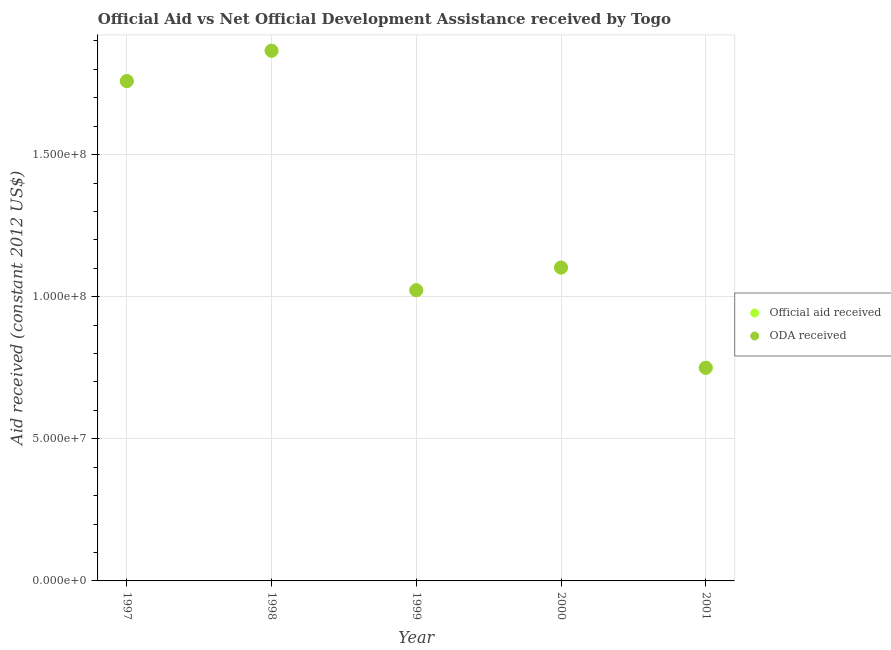How many different coloured dotlines are there?
Make the answer very short. 2. What is the official aid received in 1997?
Ensure brevity in your answer.  1.76e+08. Across all years, what is the maximum official aid received?
Provide a short and direct response. 1.87e+08. Across all years, what is the minimum official aid received?
Your answer should be compact. 7.50e+07. What is the total official aid received in the graph?
Keep it short and to the point. 6.50e+08. What is the difference between the official aid received in 1997 and that in 2000?
Offer a terse response. 6.56e+07. What is the difference between the oda received in 2001 and the official aid received in 2000?
Offer a very short reply. -3.53e+07. What is the average official aid received per year?
Provide a short and direct response. 1.30e+08. In how many years, is the oda received greater than 110000000 US$?
Give a very brief answer. 3. What is the ratio of the official aid received in 2000 to that in 2001?
Your answer should be very brief. 1.47. Is the difference between the oda received in 1997 and 1999 greater than the difference between the official aid received in 1997 and 1999?
Your response must be concise. No. What is the difference between the highest and the second highest official aid received?
Offer a terse response. 1.07e+07. What is the difference between the highest and the lowest official aid received?
Offer a terse response. 1.12e+08. In how many years, is the official aid received greater than the average official aid received taken over all years?
Ensure brevity in your answer.  2. Is the sum of the oda received in 1997 and 2001 greater than the maximum official aid received across all years?
Your answer should be compact. Yes. Does the official aid received monotonically increase over the years?
Your answer should be compact. No. Is the official aid received strictly greater than the oda received over the years?
Give a very brief answer. No. How many dotlines are there?
Ensure brevity in your answer.  2. How many years are there in the graph?
Give a very brief answer. 5. Are the values on the major ticks of Y-axis written in scientific E-notation?
Your response must be concise. Yes. Where does the legend appear in the graph?
Offer a very short reply. Center right. How many legend labels are there?
Provide a succinct answer. 2. How are the legend labels stacked?
Your answer should be very brief. Vertical. What is the title of the graph?
Give a very brief answer. Official Aid vs Net Official Development Assistance received by Togo . Does "Revenue" appear as one of the legend labels in the graph?
Provide a short and direct response. No. What is the label or title of the Y-axis?
Your answer should be compact. Aid received (constant 2012 US$). What is the Aid received (constant 2012 US$) in Official aid received in 1997?
Your answer should be compact. 1.76e+08. What is the Aid received (constant 2012 US$) in ODA received in 1997?
Make the answer very short. 1.76e+08. What is the Aid received (constant 2012 US$) in Official aid received in 1998?
Provide a short and direct response. 1.87e+08. What is the Aid received (constant 2012 US$) in ODA received in 1998?
Offer a very short reply. 1.87e+08. What is the Aid received (constant 2012 US$) in Official aid received in 1999?
Provide a short and direct response. 1.02e+08. What is the Aid received (constant 2012 US$) in ODA received in 1999?
Offer a terse response. 1.02e+08. What is the Aid received (constant 2012 US$) in Official aid received in 2000?
Your answer should be very brief. 1.10e+08. What is the Aid received (constant 2012 US$) of ODA received in 2000?
Ensure brevity in your answer.  1.10e+08. What is the Aid received (constant 2012 US$) of Official aid received in 2001?
Provide a short and direct response. 7.50e+07. What is the Aid received (constant 2012 US$) of ODA received in 2001?
Offer a very short reply. 7.50e+07. Across all years, what is the maximum Aid received (constant 2012 US$) in Official aid received?
Your answer should be very brief. 1.87e+08. Across all years, what is the maximum Aid received (constant 2012 US$) in ODA received?
Give a very brief answer. 1.87e+08. Across all years, what is the minimum Aid received (constant 2012 US$) in Official aid received?
Ensure brevity in your answer.  7.50e+07. Across all years, what is the minimum Aid received (constant 2012 US$) in ODA received?
Provide a short and direct response. 7.50e+07. What is the total Aid received (constant 2012 US$) of Official aid received in the graph?
Give a very brief answer. 6.50e+08. What is the total Aid received (constant 2012 US$) in ODA received in the graph?
Provide a succinct answer. 6.50e+08. What is the difference between the Aid received (constant 2012 US$) in Official aid received in 1997 and that in 1998?
Offer a very short reply. -1.07e+07. What is the difference between the Aid received (constant 2012 US$) in ODA received in 1997 and that in 1998?
Keep it short and to the point. -1.07e+07. What is the difference between the Aid received (constant 2012 US$) in Official aid received in 1997 and that in 1999?
Your response must be concise. 7.36e+07. What is the difference between the Aid received (constant 2012 US$) of ODA received in 1997 and that in 1999?
Your response must be concise. 7.36e+07. What is the difference between the Aid received (constant 2012 US$) of Official aid received in 1997 and that in 2000?
Provide a short and direct response. 6.56e+07. What is the difference between the Aid received (constant 2012 US$) in ODA received in 1997 and that in 2000?
Provide a short and direct response. 6.56e+07. What is the difference between the Aid received (constant 2012 US$) of Official aid received in 1997 and that in 2001?
Provide a short and direct response. 1.01e+08. What is the difference between the Aid received (constant 2012 US$) of ODA received in 1997 and that in 2001?
Your answer should be very brief. 1.01e+08. What is the difference between the Aid received (constant 2012 US$) of Official aid received in 1998 and that in 1999?
Your response must be concise. 8.43e+07. What is the difference between the Aid received (constant 2012 US$) of ODA received in 1998 and that in 1999?
Your response must be concise. 8.43e+07. What is the difference between the Aid received (constant 2012 US$) of Official aid received in 1998 and that in 2000?
Offer a terse response. 7.63e+07. What is the difference between the Aid received (constant 2012 US$) in ODA received in 1998 and that in 2000?
Make the answer very short. 7.63e+07. What is the difference between the Aid received (constant 2012 US$) in Official aid received in 1998 and that in 2001?
Make the answer very short. 1.12e+08. What is the difference between the Aid received (constant 2012 US$) in ODA received in 1998 and that in 2001?
Keep it short and to the point. 1.12e+08. What is the difference between the Aid received (constant 2012 US$) in Official aid received in 1999 and that in 2000?
Keep it short and to the point. -7.98e+06. What is the difference between the Aid received (constant 2012 US$) in ODA received in 1999 and that in 2000?
Keep it short and to the point. -7.98e+06. What is the difference between the Aid received (constant 2012 US$) in Official aid received in 1999 and that in 2001?
Make the answer very short. 2.73e+07. What is the difference between the Aid received (constant 2012 US$) in ODA received in 1999 and that in 2001?
Keep it short and to the point. 2.73e+07. What is the difference between the Aid received (constant 2012 US$) in Official aid received in 2000 and that in 2001?
Make the answer very short. 3.53e+07. What is the difference between the Aid received (constant 2012 US$) of ODA received in 2000 and that in 2001?
Provide a succinct answer. 3.53e+07. What is the difference between the Aid received (constant 2012 US$) in Official aid received in 1997 and the Aid received (constant 2012 US$) in ODA received in 1998?
Ensure brevity in your answer.  -1.07e+07. What is the difference between the Aid received (constant 2012 US$) of Official aid received in 1997 and the Aid received (constant 2012 US$) of ODA received in 1999?
Give a very brief answer. 7.36e+07. What is the difference between the Aid received (constant 2012 US$) in Official aid received in 1997 and the Aid received (constant 2012 US$) in ODA received in 2000?
Your response must be concise. 6.56e+07. What is the difference between the Aid received (constant 2012 US$) of Official aid received in 1997 and the Aid received (constant 2012 US$) of ODA received in 2001?
Ensure brevity in your answer.  1.01e+08. What is the difference between the Aid received (constant 2012 US$) of Official aid received in 1998 and the Aid received (constant 2012 US$) of ODA received in 1999?
Make the answer very short. 8.43e+07. What is the difference between the Aid received (constant 2012 US$) of Official aid received in 1998 and the Aid received (constant 2012 US$) of ODA received in 2000?
Ensure brevity in your answer.  7.63e+07. What is the difference between the Aid received (constant 2012 US$) of Official aid received in 1998 and the Aid received (constant 2012 US$) of ODA received in 2001?
Make the answer very short. 1.12e+08. What is the difference between the Aid received (constant 2012 US$) of Official aid received in 1999 and the Aid received (constant 2012 US$) of ODA received in 2000?
Offer a terse response. -7.98e+06. What is the difference between the Aid received (constant 2012 US$) in Official aid received in 1999 and the Aid received (constant 2012 US$) in ODA received in 2001?
Offer a very short reply. 2.73e+07. What is the difference between the Aid received (constant 2012 US$) in Official aid received in 2000 and the Aid received (constant 2012 US$) in ODA received in 2001?
Your answer should be very brief. 3.53e+07. What is the average Aid received (constant 2012 US$) of Official aid received per year?
Offer a very short reply. 1.30e+08. What is the average Aid received (constant 2012 US$) in ODA received per year?
Your answer should be compact. 1.30e+08. In the year 1997, what is the difference between the Aid received (constant 2012 US$) of Official aid received and Aid received (constant 2012 US$) of ODA received?
Offer a very short reply. 0. In the year 1998, what is the difference between the Aid received (constant 2012 US$) in Official aid received and Aid received (constant 2012 US$) in ODA received?
Your answer should be compact. 0. In the year 1999, what is the difference between the Aid received (constant 2012 US$) of Official aid received and Aid received (constant 2012 US$) of ODA received?
Offer a very short reply. 0. What is the ratio of the Aid received (constant 2012 US$) of Official aid received in 1997 to that in 1998?
Provide a short and direct response. 0.94. What is the ratio of the Aid received (constant 2012 US$) of ODA received in 1997 to that in 1998?
Make the answer very short. 0.94. What is the ratio of the Aid received (constant 2012 US$) in Official aid received in 1997 to that in 1999?
Give a very brief answer. 1.72. What is the ratio of the Aid received (constant 2012 US$) of ODA received in 1997 to that in 1999?
Offer a very short reply. 1.72. What is the ratio of the Aid received (constant 2012 US$) of Official aid received in 1997 to that in 2000?
Ensure brevity in your answer.  1.6. What is the ratio of the Aid received (constant 2012 US$) of ODA received in 1997 to that in 2000?
Keep it short and to the point. 1.6. What is the ratio of the Aid received (constant 2012 US$) in Official aid received in 1997 to that in 2001?
Make the answer very short. 2.35. What is the ratio of the Aid received (constant 2012 US$) in ODA received in 1997 to that in 2001?
Offer a very short reply. 2.35. What is the ratio of the Aid received (constant 2012 US$) of Official aid received in 1998 to that in 1999?
Keep it short and to the point. 1.82. What is the ratio of the Aid received (constant 2012 US$) in ODA received in 1998 to that in 1999?
Ensure brevity in your answer.  1.82. What is the ratio of the Aid received (constant 2012 US$) in Official aid received in 1998 to that in 2000?
Offer a terse response. 1.69. What is the ratio of the Aid received (constant 2012 US$) of ODA received in 1998 to that in 2000?
Your response must be concise. 1.69. What is the ratio of the Aid received (constant 2012 US$) in Official aid received in 1998 to that in 2001?
Provide a short and direct response. 2.49. What is the ratio of the Aid received (constant 2012 US$) in ODA received in 1998 to that in 2001?
Offer a very short reply. 2.49. What is the ratio of the Aid received (constant 2012 US$) of Official aid received in 1999 to that in 2000?
Offer a very short reply. 0.93. What is the ratio of the Aid received (constant 2012 US$) in ODA received in 1999 to that in 2000?
Make the answer very short. 0.93. What is the ratio of the Aid received (constant 2012 US$) of Official aid received in 1999 to that in 2001?
Make the answer very short. 1.36. What is the ratio of the Aid received (constant 2012 US$) in ODA received in 1999 to that in 2001?
Your response must be concise. 1.36. What is the ratio of the Aid received (constant 2012 US$) in Official aid received in 2000 to that in 2001?
Give a very brief answer. 1.47. What is the ratio of the Aid received (constant 2012 US$) of ODA received in 2000 to that in 2001?
Your answer should be very brief. 1.47. What is the difference between the highest and the second highest Aid received (constant 2012 US$) of Official aid received?
Offer a terse response. 1.07e+07. What is the difference between the highest and the second highest Aid received (constant 2012 US$) of ODA received?
Give a very brief answer. 1.07e+07. What is the difference between the highest and the lowest Aid received (constant 2012 US$) in Official aid received?
Keep it short and to the point. 1.12e+08. What is the difference between the highest and the lowest Aid received (constant 2012 US$) of ODA received?
Make the answer very short. 1.12e+08. 